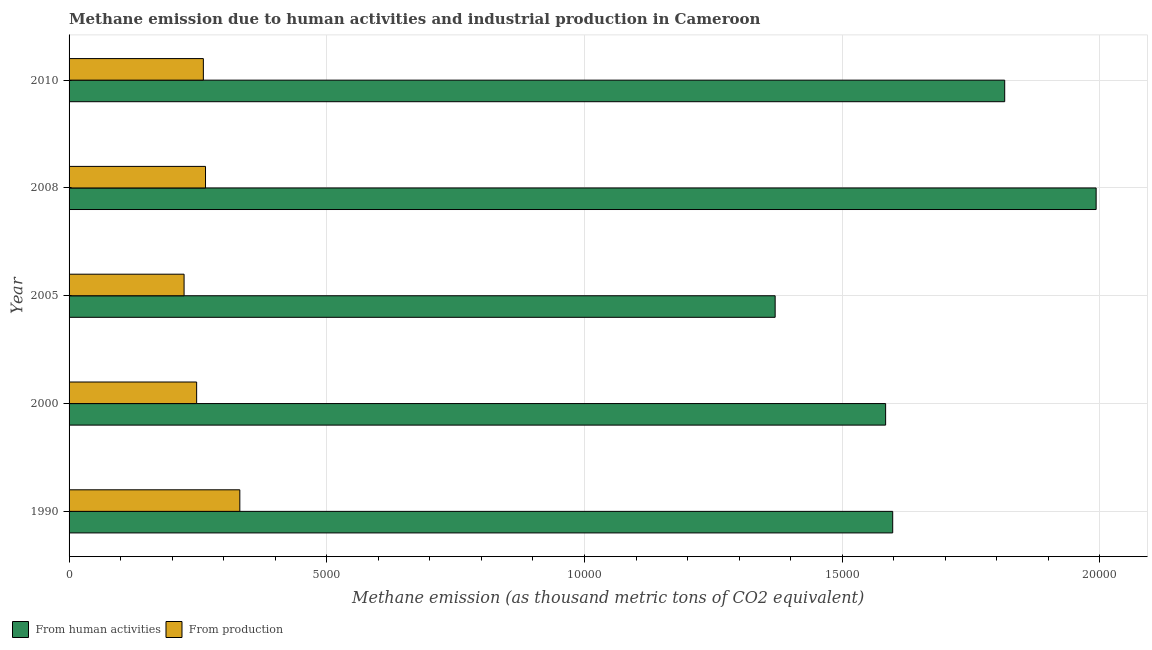How many different coloured bars are there?
Provide a short and direct response. 2. How many groups of bars are there?
Offer a very short reply. 5. Are the number of bars on each tick of the Y-axis equal?
Your answer should be compact. Yes. In how many cases, is the number of bars for a given year not equal to the number of legend labels?
Offer a terse response. 0. What is the amount of emissions from human activities in 1990?
Your answer should be very brief. 1.60e+04. Across all years, what is the maximum amount of emissions from human activities?
Ensure brevity in your answer.  1.99e+04. Across all years, what is the minimum amount of emissions generated from industries?
Keep it short and to the point. 2231.4. In which year was the amount of emissions from human activities maximum?
Offer a very short reply. 2008. In which year was the amount of emissions from human activities minimum?
Keep it short and to the point. 2005. What is the total amount of emissions generated from industries in the graph?
Make the answer very short. 1.33e+04. What is the difference between the amount of emissions generated from industries in 1990 and that in 2008?
Keep it short and to the point. 665.8. What is the difference between the amount of emissions generated from industries in 2000 and the amount of emissions from human activities in 2008?
Offer a very short reply. -1.75e+04. What is the average amount of emissions generated from industries per year?
Make the answer very short. 2654.46. In the year 2000, what is the difference between the amount of emissions from human activities and amount of emissions generated from industries?
Your answer should be very brief. 1.34e+04. In how many years, is the amount of emissions generated from industries greater than 7000 thousand metric tons?
Make the answer very short. 0. What is the ratio of the amount of emissions generated from industries in 2008 to that in 2010?
Give a very brief answer. 1.02. Is the amount of emissions from human activities in 2005 less than that in 2010?
Offer a terse response. Yes. What is the difference between the highest and the second highest amount of emissions from human activities?
Make the answer very short. 1774.1. What is the difference between the highest and the lowest amount of emissions from human activities?
Provide a succinct answer. 6227.7. In how many years, is the amount of emissions from human activities greater than the average amount of emissions from human activities taken over all years?
Give a very brief answer. 2. What does the 1st bar from the top in 1990 represents?
Your answer should be very brief. From production. What does the 2nd bar from the bottom in 2005 represents?
Keep it short and to the point. From production. Are all the bars in the graph horizontal?
Give a very brief answer. Yes. How many years are there in the graph?
Offer a very short reply. 5. Does the graph contain any zero values?
Offer a terse response. No. Does the graph contain grids?
Your response must be concise. Yes. What is the title of the graph?
Offer a terse response. Methane emission due to human activities and industrial production in Cameroon. What is the label or title of the X-axis?
Provide a succinct answer. Methane emission (as thousand metric tons of CO2 equivalent). What is the Methane emission (as thousand metric tons of CO2 equivalent) of From human activities in 1990?
Your response must be concise. 1.60e+04. What is the Methane emission (as thousand metric tons of CO2 equivalent) in From production in 1990?
Your answer should be very brief. 3313.1. What is the Methane emission (as thousand metric tons of CO2 equivalent) of From human activities in 2000?
Keep it short and to the point. 1.58e+04. What is the Methane emission (as thousand metric tons of CO2 equivalent) in From production in 2000?
Ensure brevity in your answer.  2475.1. What is the Methane emission (as thousand metric tons of CO2 equivalent) in From human activities in 2005?
Keep it short and to the point. 1.37e+04. What is the Methane emission (as thousand metric tons of CO2 equivalent) of From production in 2005?
Offer a very short reply. 2231.4. What is the Methane emission (as thousand metric tons of CO2 equivalent) in From human activities in 2008?
Your response must be concise. 1.99e+04. What is the Methane emission (as thousand metric tons of CO2 equivalent) of From production in 2008?
Ensure brevity in your answer.  2647.3. What is the Methane emission (as thousand metric tons of CO2 equivalent) of From human activities in 2010?
Keep it short and to the point. 1.82e+04. What is the Methane emission (as thousand metric tons of CO2 equivalent) of From production in 2010?
Keep it short and to the point. 2605.4. Across all years, what is the maximum Methane emission (as thousand metric tons of CO2 equivalent) in From human activities?
Your response must be concise. 1.99e+04. Across all years, what is the maximum Methane emission (as thousand metric tons of CO2 equivalent) in From production?
Offer a terse response. 3313.1. Across all years, what is the minimum Methane emission (as thousand metric tons of CO2 equivalent) of From human activities?
Your answer should be compact. 1.37e+04. Across all years, what is the minimum Methane emission (as thousand metric tons of CO2 equivalent) in From production?
Give a very brief answer. 2231.4. What is the total Methane emission (as thousand metric tons of CO2 equivalent) in From human activities in the graph?
Offer a very short reply. 8.36e+04. What is the total Methane emission (as thousand metric tons of CO2 equivalent) of From production in the graph?
Provide a short and direct response. 1.33e+04. What is the difference between the Methane emission (as thousand metric tons of CO2 equivalent) in From human activities in 1990 and that in 2000?
Your response must be concise. 137.2. What is the difference between the Methane emission (as thousand metric tons of CO2 equivalent) in From production in 1990 and that in 2000?
Your answer should be compact. 838. What is the difference between the Methane emission (as thousand metric tons of CO2 equivalent) of From human activities in 1990 and that in 2005?
Your answer should be compact. 2280.5. What is the difference between the Methane emission (as thousand metric tons of CO2 equivalent) of From production in 1990 and that in 2005?
Ensure brevity in your answer.  1081.7. What is the difference between the Methane emission (as thousand metric tons of CO2 equivalent) in From human activities in 1990 and that in 2008?
Provide a short and direct response. -3947.2. What is the difference between the Methane emission (as thousand metric tons of CO2 equivalent) in From production in 1990 and that in 2008?
Your response must be concise. 665.8. What is the difference between the Methane emission (as thousand metric tons of CO2 equivalent) in From human activities in 1990 and that in 2010?
Make the answer very short. -2173.1. What is the difference between the Methane emission (as thousand metric tons of CO2 equivalent) in From production in 1990 and that in 2010?
Provide a short and direct response. 707.7. What is the difference between the Methane emission (as thousand metric tons of CO2 equivalent) in From human activities in 2000 and that in 2005?
Make the answer very short. 2143.3. What is the difference between the Methane emission (as thousand metric tons of CO2 equivalent) of From production in 2000 and that in 2005?
Offer a terse response. 243.7. What is the difference between the Methane emission (as thousand metric tons of CO2 equivalent) of From human activities in 2000 and that in 2008?
Your answer should be compact. -4084.4. What is the difference between the Methane emission (as thousand metric tons of CO2 equivalent) of From production in 2000 and that in 2008?
Provide a succinct answer. -172.2. What is the difference between the Methane emission (as thousand metric tons of CO2 equivalent) in From human activities in 2000 and that in 2010?
Offer a terse response. -2310.3. What is the difference between the Methane emission (as thousand metric tons of CO2 equivalent) in From production in 2000 and that in 2010?
Provide a short and direct response. -130.3. What is the difference between the Methane emission (as thousand metric tons of CO2 equivalent) in From human activities in 2005 and that in 2008?
Your answer should be compact. -6227.7. What is the difference between the Methane emission (as thousand metric tons of CO2 equivalent) of From production in 2005 and that in 2008?
Your answer should be very brief. -415.9. What is the difference between the Methane emission (as thousand metric tons of CO2 equivalent) in From human activities in 2005 and that in 2010?
Make the answer very short. -4453.6. What is the difference between the Methane emission (as thousand metric tons of CO2 equivalent) in From production in 2005 and that in 2010?
Give a very brief answer. -374. What is the difference between the Methane emission (as thousand metric tons of CO2 equivalent) of From human activities in 2008 and that in 2010?
Your answer should be compact. 1774.1. What is the difference between the Methane emission (as thousand metric tons of CO2 equivalent) in From production in 2008 and that in 2010?
Offer a terse response. 41.9. What is the difference between the Methane emission (as thousand metric tons of CO2 equivalent) of From human activities in 1990 and the Methane emission (as thousand metric tons of CO2 equivalent) of From production in 2000?
Make the answer very short. 1.35e+04. What is the difference between the Methane emission (as thousand metric tons of CO2 equivalent) of From human activities in 1990 and the Methane emission (as thousand metric tons of CO2 equivalent) of From production in 2005?
Ensure brevity in your answer.  1.37e+04. What is the difference between the Methane emission (as thousand metric tons of CO2 equivalent) of From human activities in 1990 and the Methane emission (as thousand metric tons of CO2 equivalent) of From production in 2008?
Your answer should be very brief. 1.33e+04. What is the difference between the Methane emission (as thousand metric tons of CO2 equivalent) of From human activities in 1990 and the Methane emission (as thousand metric tons of CO2 equivalent) of From production in 2010?
Provide a short and direct response. 1.34e+04. What is the difference between the Methane emission (as thousand metric tons of CO2 equivalent) of From human activities in 2000 and the Methane emission (as thousand metric tons of CO2 equivalent) of From production in 2005?
Keep it short and to the point. 1.36e+04. What is the difference between the Methane emission (as thousand metric tons of CO2 equivalent) in From human activities in 2000 and the Methane emission (as thousand metric tons of CO2 equivalent) in From production in 2008?
Your answer should be very brief. 1.32e+04. What is the difference between the Methane emission (as thousand metric tons of CO2 equivalent) of From human activities in 2000 and the Methane emission (as thousand metric tons of CO2 equivalent) of From production in 2010?
Give a very brief answer. 1.32e+04. What is the difference between the Methane emission (as thousand metric tons of CO2 equivalent) of From human activities in 2005 and the Methane emission (as thousand metric tons of CO2 equivalent) of From production in 2008?
Give a very brief answer. 1.11e+04. What is the difference between the Methane emission (as thousand metric tons of CO2 equivalent) in From human activities in 2005 and the Methane emission (as thousand metric tons of CO2 equivalent) in From production in 2010?
Give a very brief answer. 1.11e+04. What is the difference between the Methane emission (as thousand metric tons of CO2 equivalent) of From human activities in 2008 and the Methane emission (as thousand metric tons of CO2 equivalent) of From production in 2010?
Provide a short and direct response. 1.73e+04. What is the average Methane emission (as thousand metric tons of CO2 equivalent) of From human activities per year?
Your response must be concise. 1.67e+04. What is the average Methane emission (as thousand metric tons of CO2 equivalent) in From production per year?
Offer a terse response. 2654.46. In the year 1990, what is the difference between the Methane emission (as thousand metric tons of CO2 equivalent) in From human activities and Methane emission (as thousand metric tons of CO2 equivalent) in From production?
Provide a short and direct response. 1.27e+04. In the year 2000, what is the difference between the Methane emission (as thousand metric tons of CO2 equivalent) in From human activities and Methane emission (as thousand metric tons of CO2 equivalent) in From production?
Provide a short and direct response. 1.34e+04. In the year 2005, what is the difference between the Methane emission (as thousand metric tons of CO2 equivalent) of From human activities and Methane emission (as thousand metric tons of CO2 equivalent) of From production?
Keep it short and to the point. 1.15e+04. In the year 2008, what is the difference between the Methane emission (as thousand metric tons of CO2 equivalent) in From human activities and Methane emission (as thousand metric tons of CO2 equivalent) in From production?
Your answer should be very brief. 1.73e+04. In the year 2010, what is the difference between the Methane emission (as thousand metric tons of CO2 equivalent) in From human activities and Methane emission (as thousand metric tons of CO2 equivalent) in From production?
Your answer should be compact. 1.55e+04. What is the ratio of the Methane emission (as thousand metric tons of CO2 equivalent) in From human activities in 1990 to that in 2000?
Ensure brevity in your answer.  1.01. What is the ratio of the Methane emission (as thousand metric tons of CO2 equivalent) of From production in 1990 to that in 2000?
Make the answer very short. 1.34. What is the ratio of the Methane emission (as thousand metric tons of CO2 equivalent) in From human activities in 1990 to that in 2005?
Offer a very short reply. 1.17. What is the ratio of the Methane emission (as thousand metric tons of CO2 equivalent) of From production in 1990 to that in 2005?
Offer a very short reply. 1.48. What is the ratio of the Methane emission (as thousand metric tons of CO2 equivalent) of From human activities in 1990 to that in 2008?
Offer a terse response. 0.8. What is the ratio of the Methane emission (as thousand metric tons of CO2 equivalent) in From production in 1990 to that in 2008?
Your response must be concise. 1.25. What is the ratio of the Methane emission (as thousand metric tons of CO2 equivalent) in From human activities in 1990 to that in 2010?
Offer a very short reply. 0.88. What is the ratio of the Methane emission (as thousand metric tons of CO2 equivalent) in From production in 1990 to that in 2010?
Provide a short and direct response. 1.27. What is the ratio of the Methane emission (as thousand metric tons of CO2 equivalent) of From human activities in 2000 to that in 2005?
Offer a very short reply. 1.16. What is the ratio of the Methane emission (as thousand metric tons of CO2 equivalent) in From production in 2000 to that in 2005?
Offer a terse response. 1.11. What is the ratio of the Methane emission (as thousand metric tons of CO2 equivalent) of From human activities in 2000 to that in 2008?
Offer a very short reply. 0.8. What is the ratio of the Methane emission (as thousand metric tons of CO2 equivalent) in From production in 2000 to that in 2008?
Your answer should be very brief. 0.94. What is the ratio of the Methane emission (as thousand metric tons of CO2 equivalent) in From human activities in 2000 to that in 2010?
Your response must be concise. 0.87. What is the ratio of the Methane emission (as thousand metric tons of CO2 equivalent) of From production in 2000 to that in 2010?
Give a very brief answer. 0.95. What is the ratio of the Methane emission (as thousand metric tons of CO2 equivalent) in From human activities in 2005 to that in 2008?
Give a very brief answer. 0.69. What is the ratio of the Methane emission (as thousand metric tons of CO2 equivalent) in From production in 2005 to that in 2008?
Offer a terse response. 0.84. What is the ratio of the Methane emission (as thousand metric tons of CO2 equivalent) of From human activities in 2005 to that in 2010?
Provide a short and direct response. 0.75. What is the ratio of the Methane emission (as thousand metric tons of CO2 equivalent) of From production in 2005 to that in 2010?
Your answer should be compact. 0.86. What is the ratio of the Methane emission (as thousand metric tons of CO2 equivalent) in From human activities in 2008 to that in 2010?
Make the answer very short. 1.1. What is the ratio of the Methane emission (as thousand metric tons of CO2 equivalent) of From production in 2008 to that in 2010?
Your answer should be compact. 1.02. What is the difference between the highest and the second highest Methane emission (as thousand metric tons of CO2 equivalent) of From human activities?
Give a very brief answer. 1774.1. What is the difference between the highest and the second highest Methane emission (as thousand metric tons of CO2 equivalent) in From production?
Your answer should be compact. 665.8. What is the difference between the highest and the lowest Methane emission (as thousand metric tons of CO2 equivalent) of From human activities?
Offer a terse response. 6227.7. What is the difference between the highest and the lowest Methane emission (as thousand metric tons of CO2 equivalent) in From production?
Provide a succinct answer. 1081.7. 